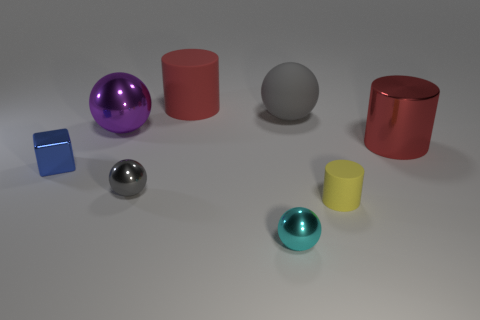Subtract all yellow spheres. Subtract all red cubes. How many spheres are left? 4 Add 1 cyan balls. How many objects exist? 9 Subtract all cylinders. How many objects are left? 5 Add 5 large metallic balls. How many large metallic balls are left? 6 Add 4 cyan metallic things. How many cyan metallic things exist? 5 Subtract 0 cyan cylinders. How many objects are left? 8 Subtract all tiny cylinders. Subtract all small blue objects. How many objects are left? 6 